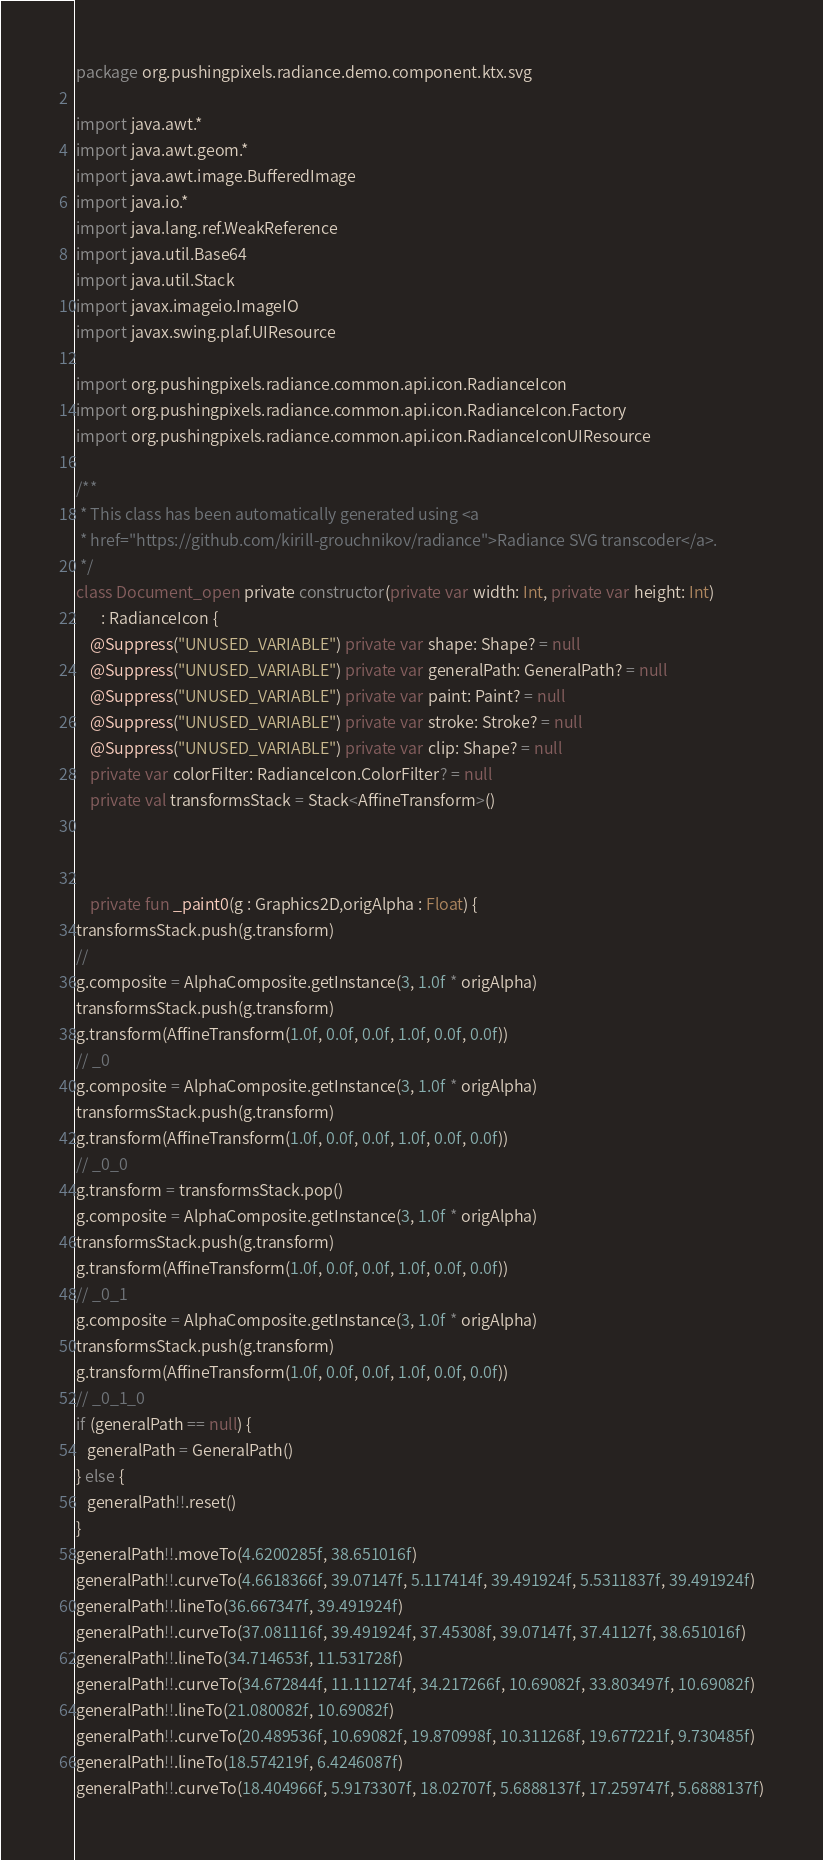Convert code to text. <code><loc_0><loc_0><loc_500><loc_500><_Kotlin_>package org.pushingpixels.radiance.demo.component.ktx.svg

import java.awt.*
import java.awt.geom.*
import java.awt.image.BufferedImage
import java.io.*
import java.lang.ref.WeakReference
import java.util.Base64
import java.util.Stack
import javax.imageio.ImageIO
import javax.swing.plaf.UIResource

import org.pushingpixels.radiance.common.api.icon.RadianceIcon
import org.pushingpixels.radiance.common.api.icon.RadianceIcon.Factory
import org.pushingpixels.radiance.common.api.icon.RadianceIconUIResource

/**
 * This class has been automatically generated using <a
 * href="https://github.com/kirill-grouchnikov/radiance">Radiance SVG transcoder</a>.
 */
class Document_open private constructor(private var width: Int, private var height: Int)
       : RadianceIcon {
    @Suppress("UNUSED_VARIABLE") private var shape: Shape? = null
    @Suppress("UNUSED_VARIABLE") private var generalPath: GeneralPath? = null
    @Suppress("UNUSED_VARIABLE") private var paint: Paint? = null
    @Suppress("UNUSED_VARIABLE") private var stroke: Stroke? = null
    @Suppress("UNUSED_VARIABLE") private var clip: Shape? = null
    private var colorFilter: RadianceIcon.ColorFilter? = null
    private val transformsStack = Stack<AffineTransform>()

    

	private fun _paint0(g : Graphics2D,origAlpha : Float) {
transformsStack.push(g.transform)
// 
g.composite = AlphaComposite.getInstance(3, 1.0f * origAlpha)
transformsStack.push(g.transform)
g.transform(AffineTransform(1.0f, 0.0f, 0.0f, 1.0f, 0.0f, 0.0f))
// _0
g.composite = AlphaComposite.getInstance(3, 1.0f * origAlpha)
transformsStack.push(g.transform)
g.transform(AffineTransform(1.0f, 0.0f, 0.0f, 1.0f, 0.0f, 0.0f))
// _0_0
g.transform = transformsStack.pop()
g.composite = AlphaComposite.getInstance(3, 1.0f * origAlpha)
transformsStack.push(g.transform)
g.transform(AffineTransform(1.0f, 0.0f, 0.0f, 1.0f, 0.0f, 0.0f))
// _0_1
g.composite = AlphaComposite.getInstance(3, 1.0f * origAlpha)
transformsStack.push(g.transform)
g.transform(AffineTransform(1.0f, 0.0f, 0.0f, 1.0f, 0.0f, 0.0f))
// _0_1_0
if (generalPath == null) {
   generalPath = GeneralPath()
} else {
   generalPath!!.reset()
}
generalPath!!.moveTo(4.6200285f, 38.651016f)
generalPath!!.curveTo(4.6618366f, 39.07147f, 5.117414f, 39.491924f, 5.5311837f, 39.491924f)
generalPath!!.lineTo(36.667347f, 39.491924f)
generalPath!!.curveTo(37.081116f, 39.491924f, 37.45308f, 39.07147f, 37.41127f, 38.651016f)
generalPath!!.lineTo(34.714653f, 11.531728f)
generalPath!!.curveTo(34.672844f, 11.111274f, 34.217266f, 10.69082f, 33.803497f, 10.69082f)
generalPath!!.lineTo(21.080082f, 10.69082f)
generalPath!!.curveTo(20.489536f, 10.69082f, 19.870998f, 10.311268f, 19.677221f, 9.730485f)
generalPath!!.lineTo(18.574219f, 6.4246087f)
generalPath!!.curveTo(18.404966f, 5.9173307f, 18.02707f, 5.6888137f, 17.259747f, 5.6888137f)</code> 